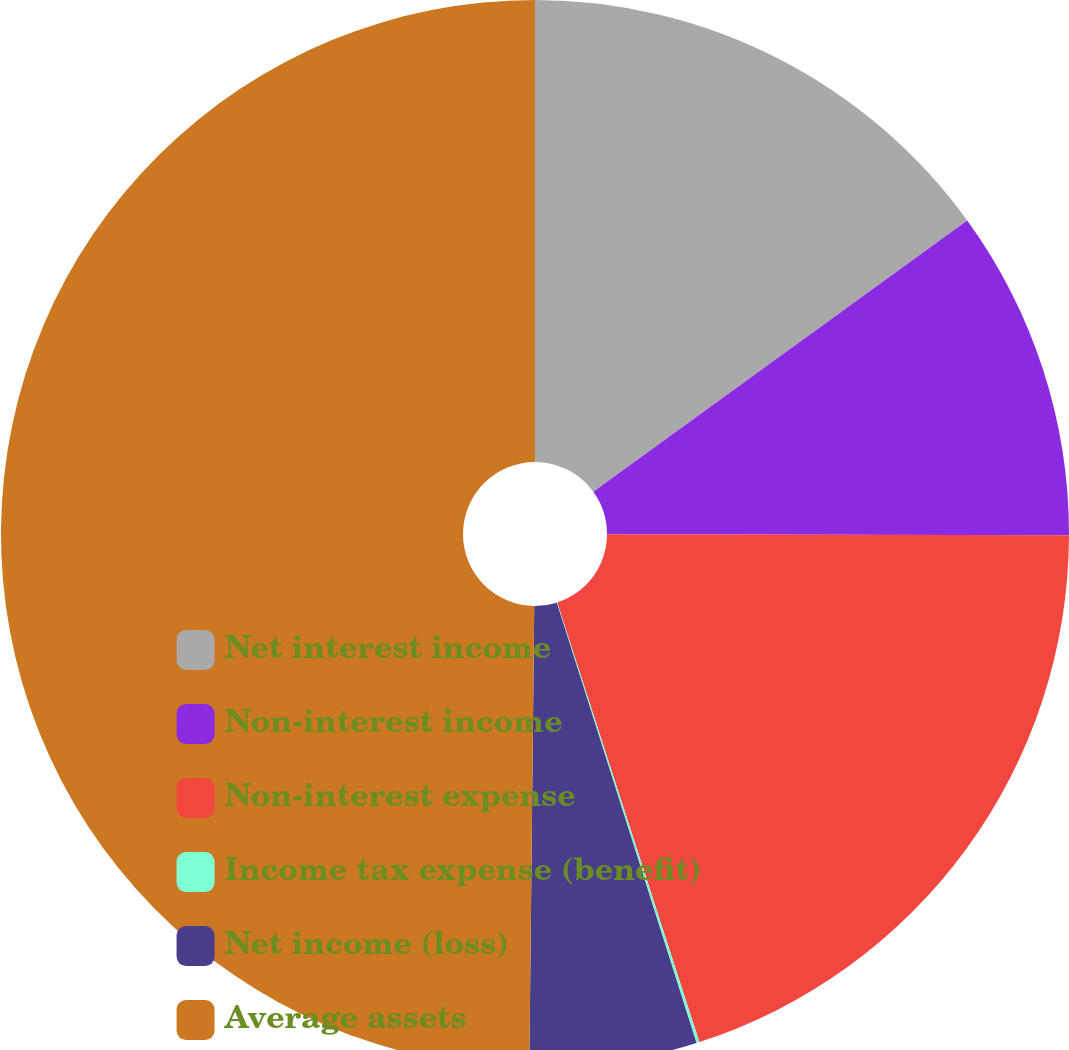Convert chart. <chart><loc_0><loc_0><loc_500><loc_500><pie_chart><fcel>Net interest income<fcel>Non-interest income<fcel>Non-interest expense<fcel>Income tax expense (benefit)<fcel>Net income (loss)<fcel>Average assets<nl><fcel>15.01%<fcel>10.03%<fcel>19.98%<fcel>0.09%<fcel>5.06%<fcel>49.83%<nl></chart> 